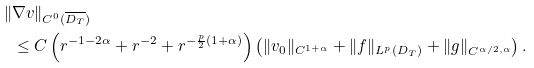<formula> <loc_0><loc_0><loc_500><loc_500>\| & \nabla v \| _ { C ^ { 0 } ( \overline { D _ { T } } ) } \\ & \leq C \left ( r ^ { - 1 - 2 \alpha } + r ^ { - 2 } + r ^ { - \frac { p } { 2 } ( 1 + \alpha ) } \right ) \left ( \| v _ { 0 } \| _ { C ^ { 1 + \alpha } } + \| f \| _ { L ^ { p } ( D _ { T } ) } + \| g \| _ { C ^ { \alpha / 2 , \alpha } } \right ) .</formula> 